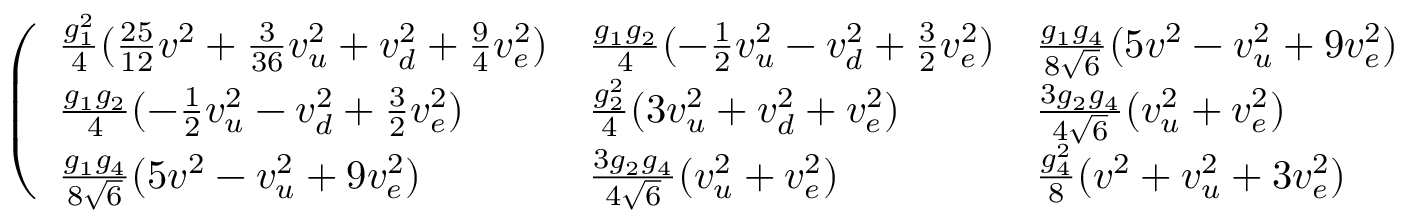<formula> <loc_0><loc_0><loc_500><loc_500>\left ( \begin{array} { l l l } { { { \frac { g _ { 1 } ^ { 2 } } { 4 } } ( { \frac { 2 5 } { 1 2 } } v ^ { 2 } + { \frac { 3 } { 3 6 } } v _ { u } ^ { 2 } + v _ { d } ^ { 2 } + { \frac { 9 } { 4 } } v _ { e } ^ { 2 } ) } } & { { { \frac { g _ { 1 } g _ { 2 } } { 4 } } ( - { \frac { 1 } { 2 } } v _ { u } ^ { 2 } - v _ { d } ^ { 2 } + { \frac { 3 } { 2 } } v _ { e } ^ { 2 } ) } } & { { { \frac { g _ { 1 } g _ { 4 } } { 8 \sqrt { 6 } } } ( 5 v ^ { 2 } - v _ { u } ^ { 2 } + 9 v _ { e } ^ { 2 } ) } } \\ { { { \frac { g _ { 1 } g _ { 2 } } { 4 } } ( - { \frac { 1 } { 2 } } v _ { u } ^ { 2 } - v _ { d } ^ { 2 } + { \frac { 3 } { 2 } } v _ { e } ^ { 2 } ) } } & { { { \frac { g _ { 2 } ^ { 2 } } { 4 } } ( 3 v _ { u } ^ { 2 } + v _ { d } ^ { 2 } + v _ { e } ^ { 2 } ) } } & { { { \frac { 3 g _ { 2 } g _ { 4 } } { 4 \sqrt { 6 } } } ( v _ { u } ^ { 2 } + v _ { e } ^ { 2 } ) } } \\ { { { \frac { g _ { 1 } g _ { 4 } } { 8 \sqrt { 6 } } } ( 5 v ^ { 2 } - v _ { u } ^ { 2 } + 9 v _ { e } ^ { 2 } ) } } & { { { \frac { 3 g _ { 2 } g _ { 4 } } { 4 \sqrt { 6 } } } ( v _ { u } ^ { 2 } + v _ { e } ^ { 2 } ) } } & { { { \frac { g _ { 4 } ^ { 2 } } { 8 } } ( v ^ { 2 } + v _ { u } ^ { 2 } + 3 v _ { e } ^ { 2 } ) } } \end{array} \right )</formula> 